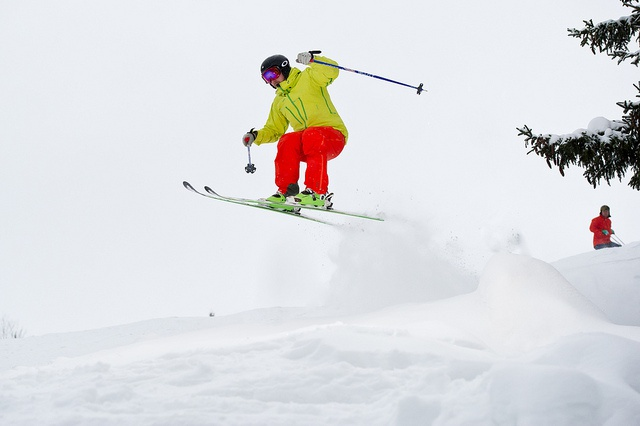Describe the objects in this image and their specific colors. I can see people in white, red, olive, and khaki tones, skis in white, lightgray, darkgray, green, and gray tones, and people in white, brown, gray, and maroon tones in this image. 